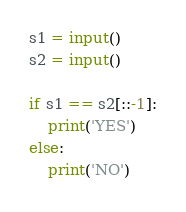<code> <loc_0><loc_0><loc_500><loc_500><_Python_>s1 = input()
s2 = input()

if s1 == s2[::-1]:
    print('YES')
else:
    print('NO')</code> 